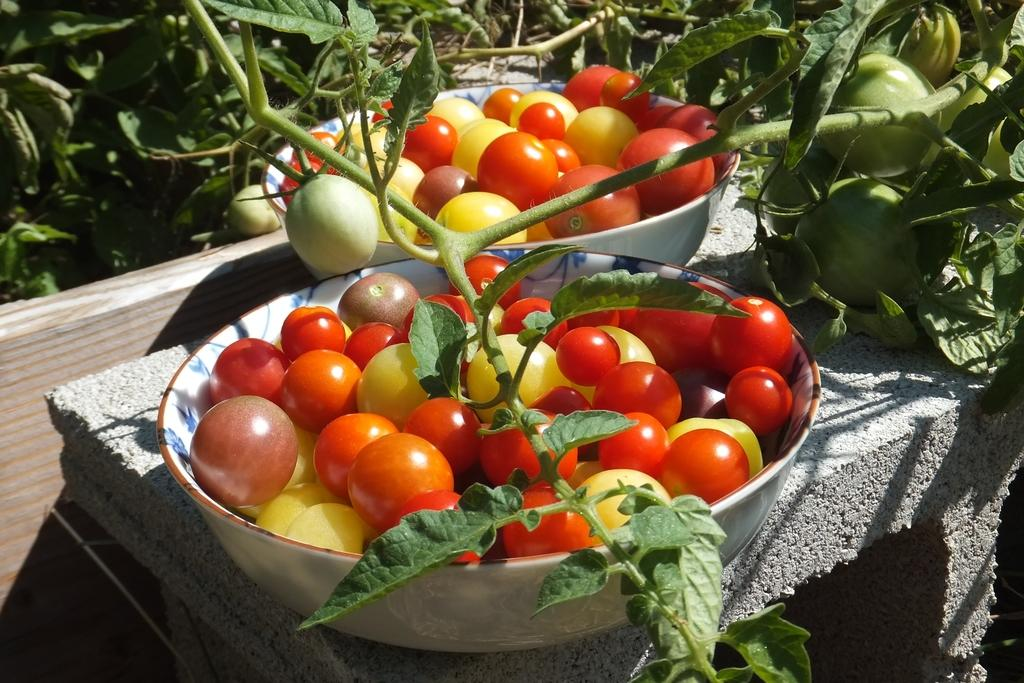What type of fruit or vegetable can be seen in the image? There are tomatoes in the image. How are the tomatoes arranged or displayed in the image? The tomatoes are kept in white color bowls. Where are the bowls with tomatoes located in the image? The bowls are in the middle of the image. What can be seen in the background of the image? There are stems and leaves visible in the background of the image. What does your aunt say about the tomatoes in the image? There is no mention of an aunt in the image or the provided facts, so we cannot answer this question. 